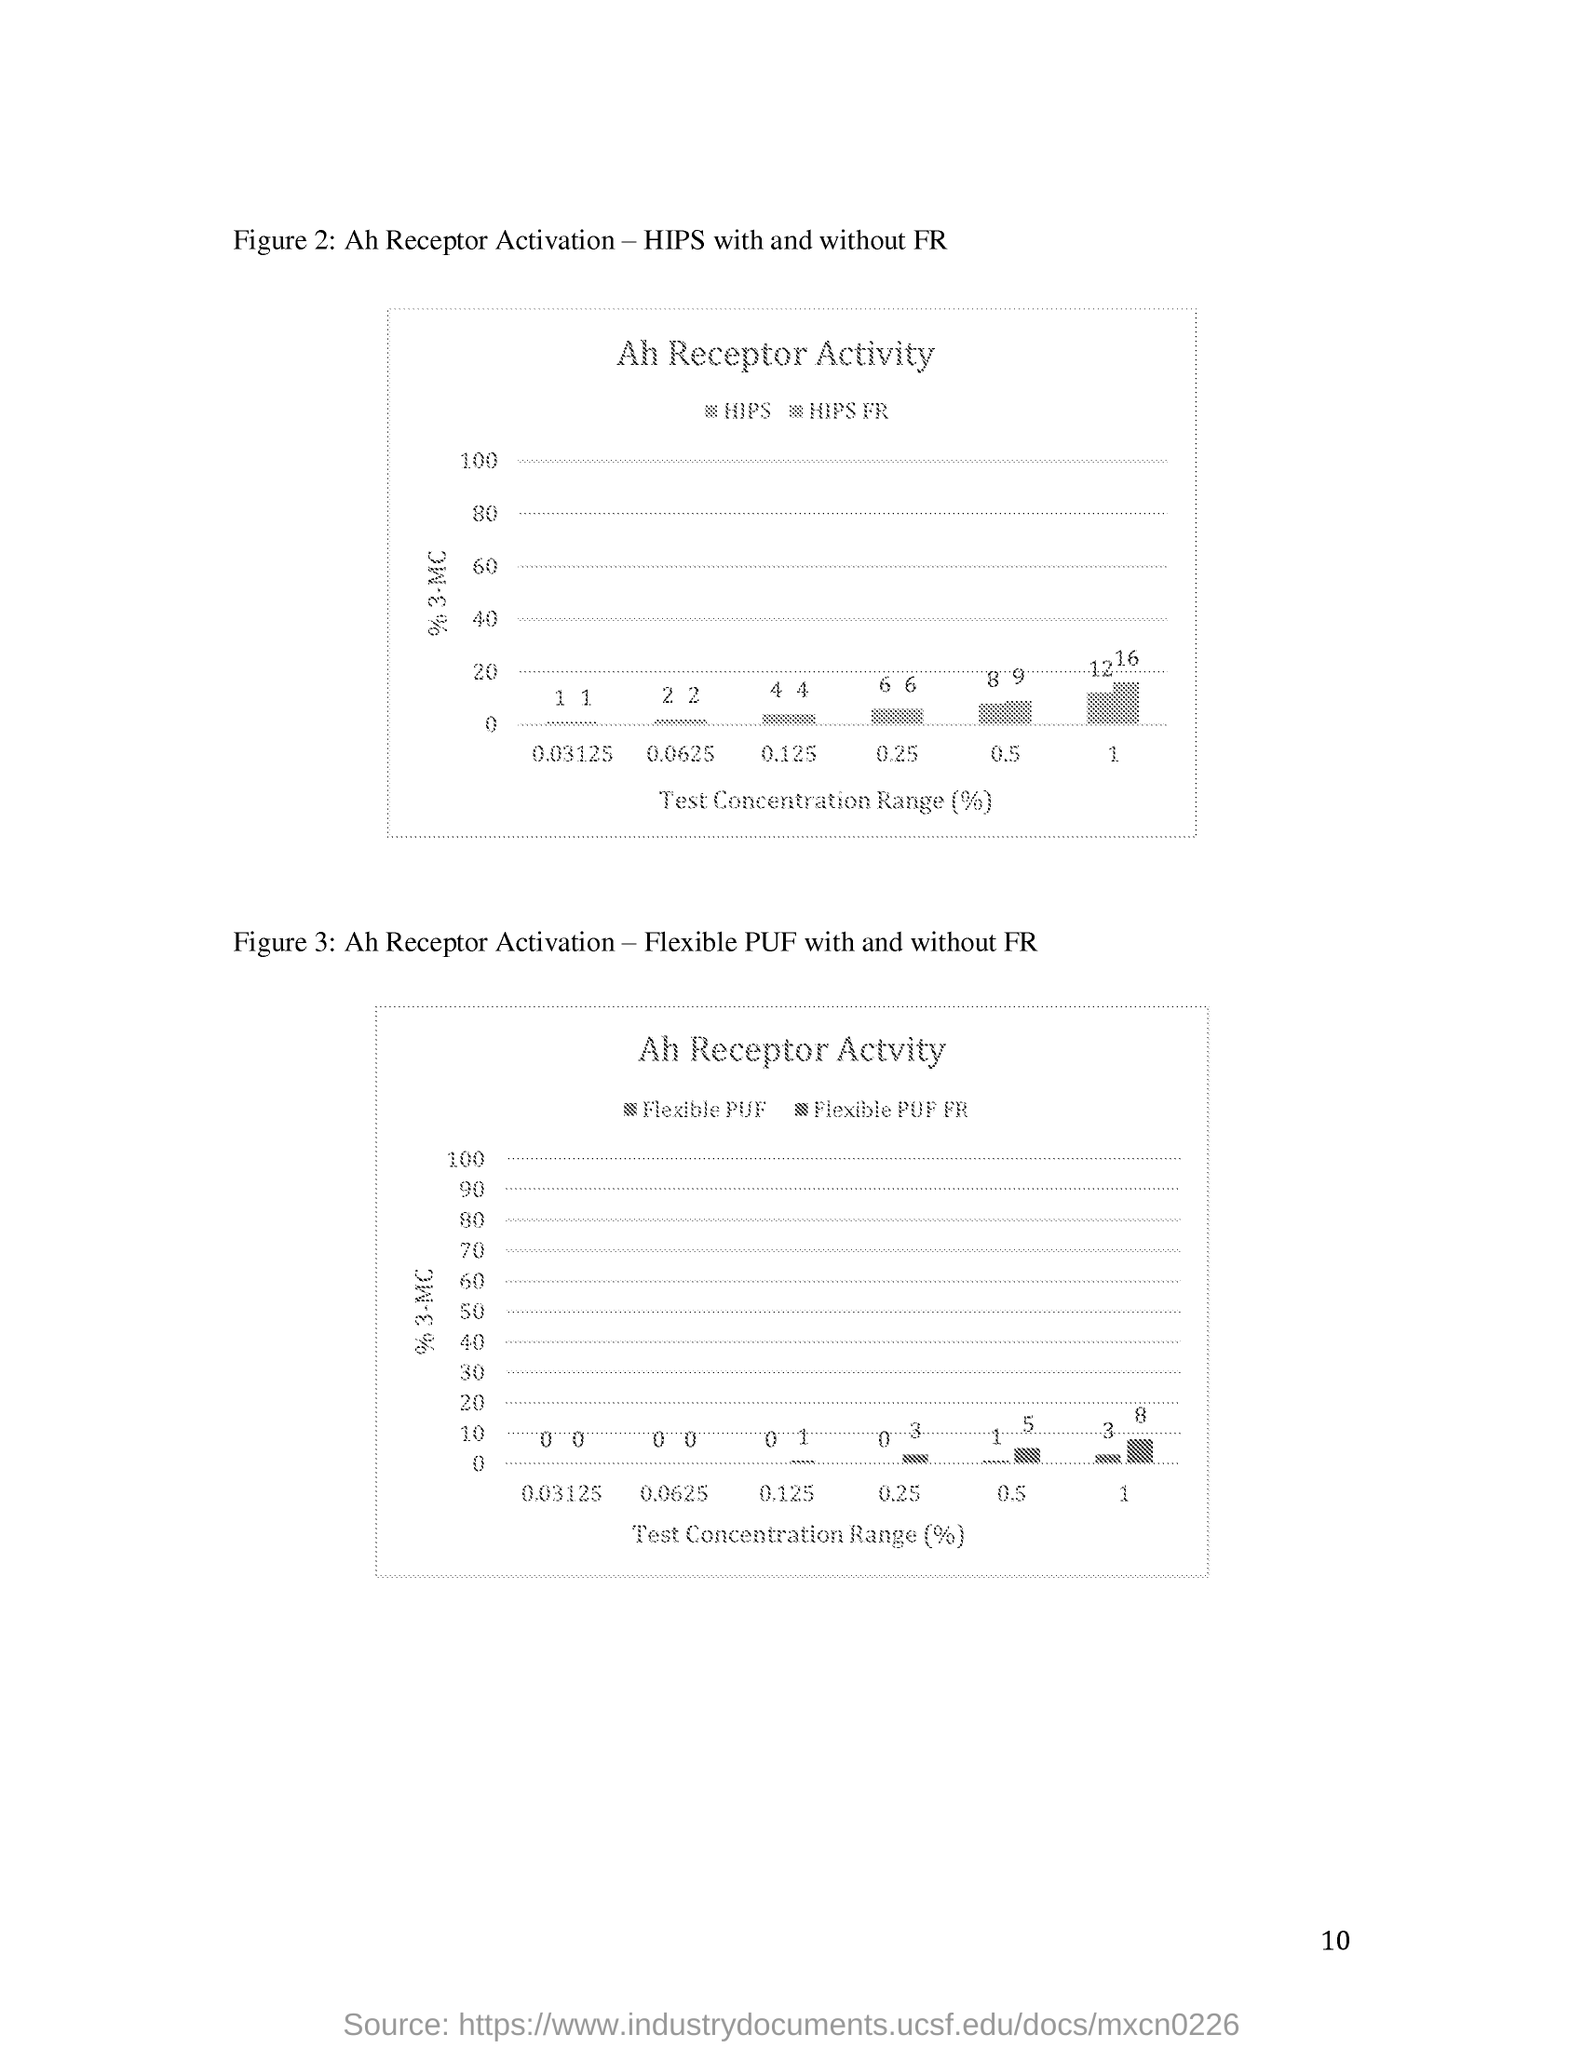What does Figure 2 represents?
Your answer should be compact. Ah Receptor Activation - HIPS with and without FR. What is the page no mentioned in this document?
Give a very brief answer. 10. 